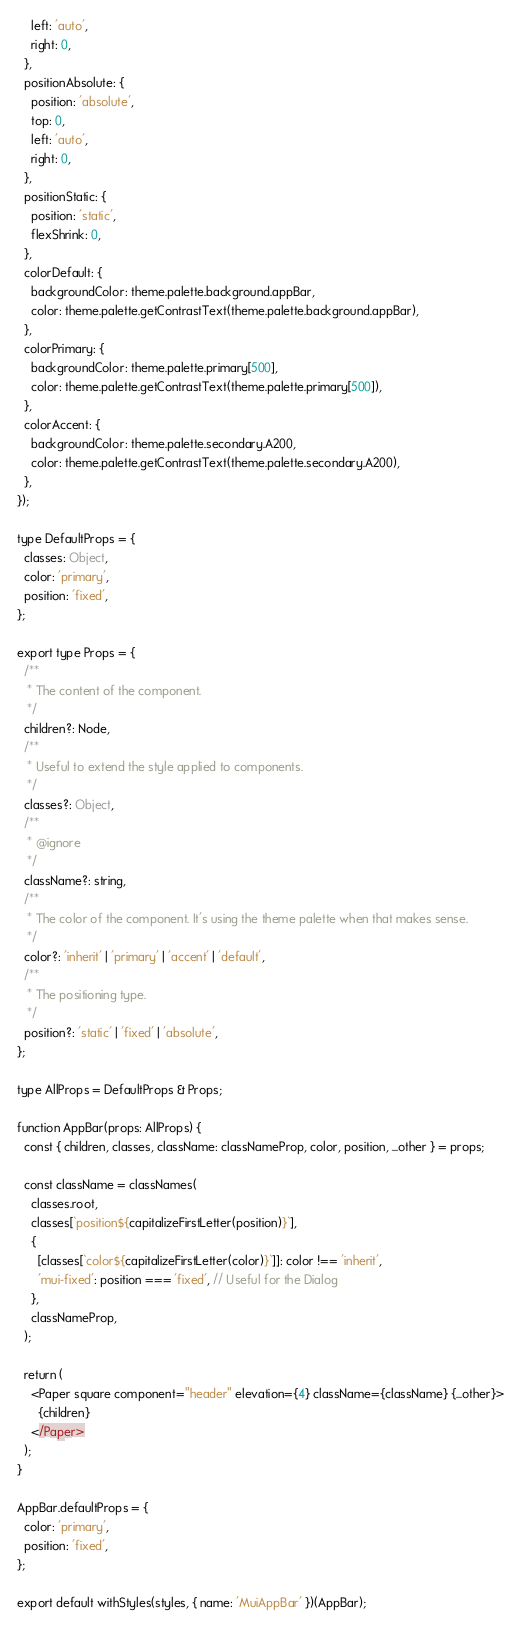<code> <loc_0><loc_0><loc_500><loc_500><_JavaScript_>    left: 'auto',
    right: 0,
  },
  positionAbsolute: {
    position: 'absolute',
    top: 0,
    left: 'auto',
    right: 0,
  },
  positionStatic: {
    position: 'static',
    flexShrink: 0,
  },
  colorDefault: {
    backgroundColor: theme.palette.background.appBar,
    color: theme.palette.getContrastText(theme.palette.background.appBar),
  },
  colorPrimary: {
    backgroundColor: theme.palette.primary[500],
    color: theme.palette.getContrastText(theme.palette.primary[500]),
  },
  colorAccent: {
    backgroundColor: theme.palette.secondary.A200,
    color: theme.palette.getContrastText(theme.palette.secondary.A200),
  },
});

type DefaultProps = {
  classes: Object,
  color: 'primary',
  position: 'fixed',
};

export type Props = {
  /**
   * The content of the component.
   */
  children?: Node,
  /**
   * Useful to extend the style applied to components.
   */
  classes?: Object,
  /**
   * @ignore
   */
  className?: string,
  /**
   * The color of the component. It's using the theme palette when that makes sense.
   */
  color?: 'inherit' | 'primary' | 'accent' | 'default',
  /**
   * The positioning type.
   */
  position?: 'static' | 'fixed' | 'absolute',
};

type AllProps = DefaultProps & Props;

function AppBar(props: AllProps) {
  const { children, classes, className: classNameProp, color, position, ...other } = props;

  const className = classNames(
    classes.root,
    classes[`position${capitalizeFirstLetter(position)}`],
    {
      [classes[`color${capitalizeFirstLetter(color)}`]]: color !== 'inherit',
      'mui-fixed': position === 'fixed', // Useful for the Dialog
    },
    classNameProp,
  );

  return (
    <Paper square component="header" elevation={4} className={className} {...other}>
      {children}
    </Paper>
  );
}

AppBar.defaultProps = {
  color: 'primary',
  position: 'fixed',
};

export default withStyles(styles, { name: 'MuiAppBar' })(AppBar);
</code> 